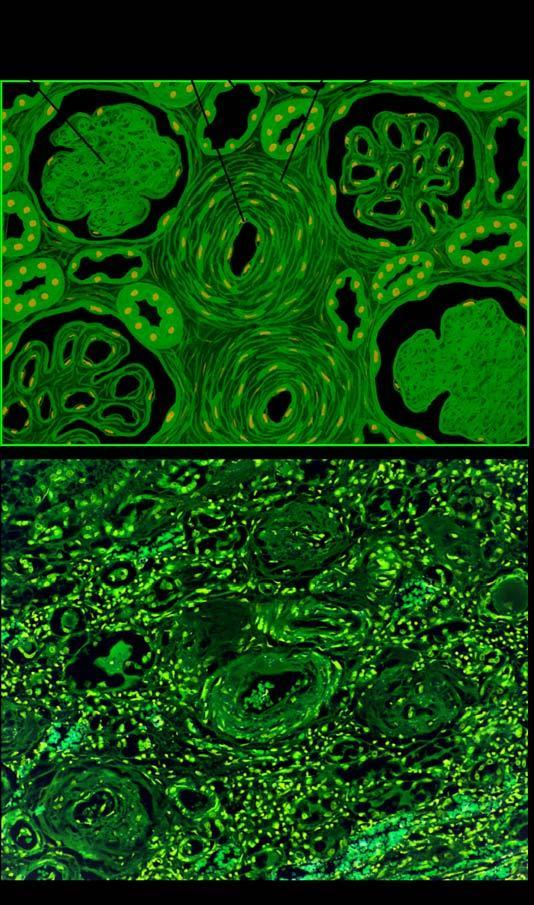what do the parenchymal changes include?
Answer the question using a single word or phrase. Sclerosed glomeruli 